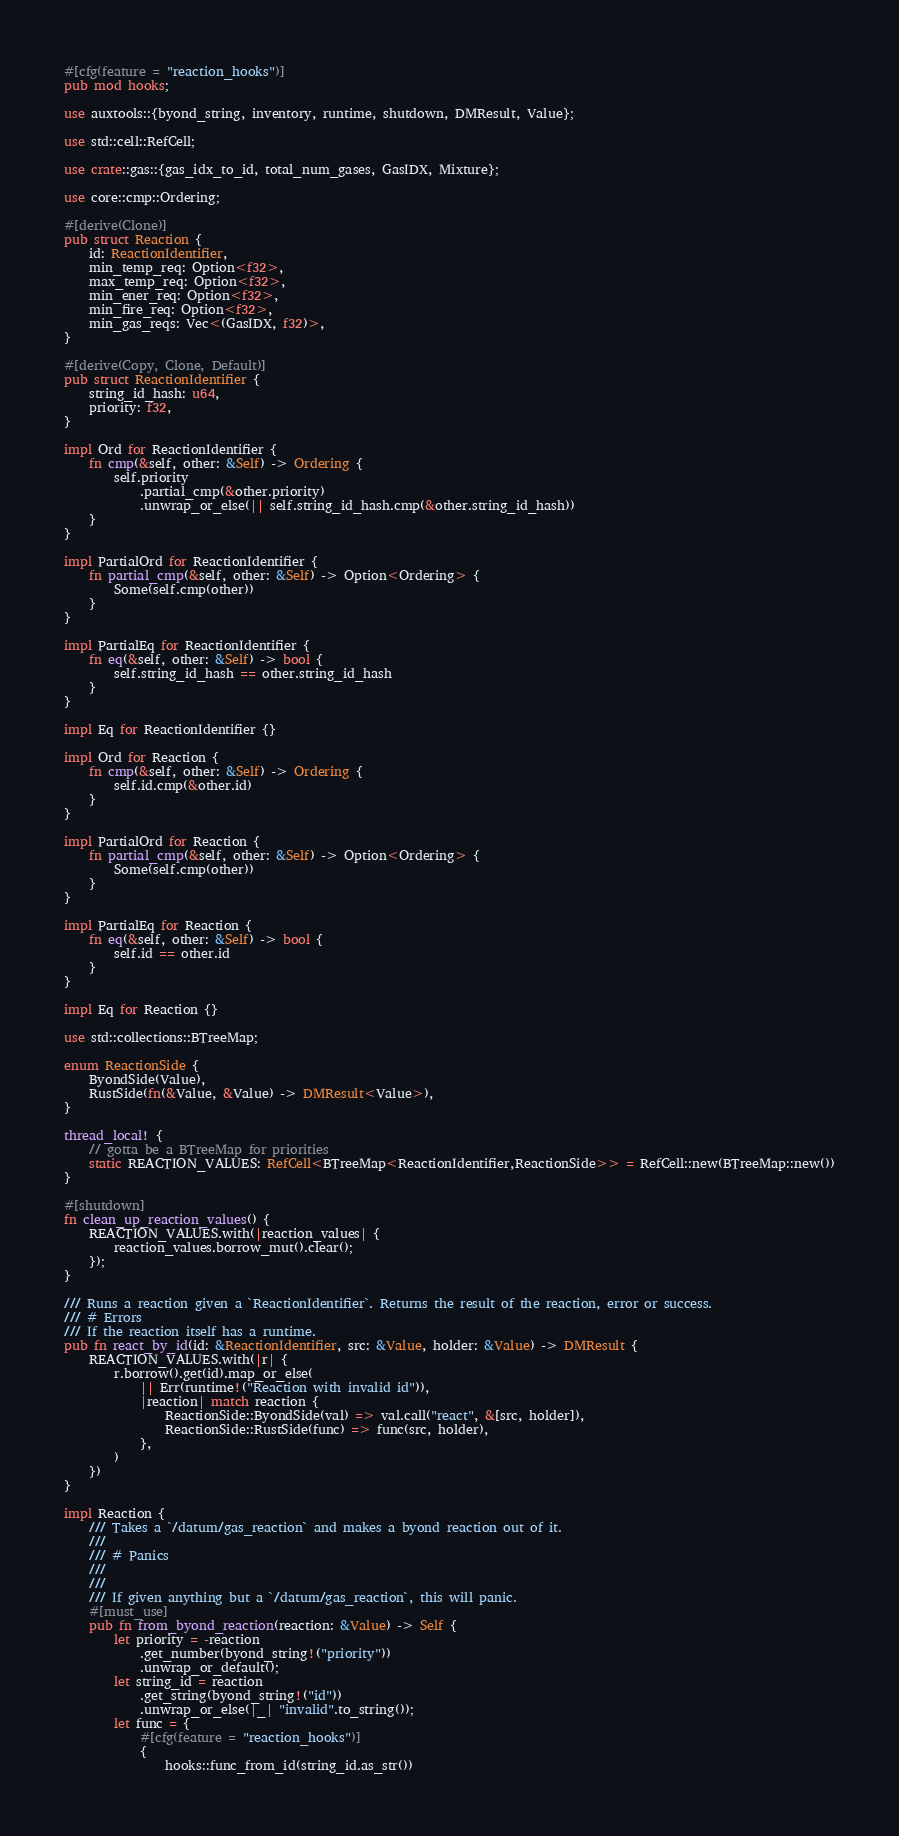<code> <loc_0><loc_0><loc_500><loc_500><_Rust_>#[cfg(feature = "reaction_hooks")]
pub mod hooks;

use auxtools::{byond_string, inventory, runtime, shutdown, DMResult, Value};

use std::cell::RefCell;

use crate::gas::{gas_idx_to_id, total_num_gases, GasIDX, Mixture};

use core::cmp::Ordering;

#[derive(Clone)]
pub struct Reaction {
	id: ReactionIdentifier,
	min_temp_req: Option<f32>,
	max_temp_req: Option<f32>,
	min_ener_req: Option<f32>,
	min_fire_req: Option<f32>,
	min_gas_reqs: Vec<(GasIDX, f32)>,
}

#[derive(Copy, Clone, Default)]
pub struct ReactionIdentifier {
	string_id_hash: u64,
	priority: f32,
}

impl Ord for ReactionIdentifier {
	fn cmp(&self, other: &Self) -> Ordering {
		self.priority
			.partial_cmp(&other.priority)
			.unwrap_or_else(|| self.string_id_hash.cmp(&other.string_id_hash))
	}
}

impl PartialOrd for ReactionIdentifier {
	fn partial_cmp(&self, other: &Self) -> Option<Ordering> {
		Some(self.cmp(other))
	}
}

impl PartialEq for ReactionIdentifier {
	fn eq(&self, other: &Self) -> bool {
		self.string_id_hash == other.string_id_hash
	}
}

impl Eq for ReactionIdentifier {}

impl Ord for Reaction {
	fn cmp(&self, other: &Self) -> Ordering {
		self.id.cmp(&other.id)
	}
}

impl PartialOrd for Reaction {
	fn partial_cmp(&self, other: &Self) -> Option<Ordering> {
		Some(self.cmp(other))
	}
}

impl PartialEq for Reaction {
	fn eq(&self, other: &Self) -> bool {
		self.id == other.id
	}
}

impl Eq for Reaction {}

use std::collections::BTreeMap;

enum ReactionSide {
	ByondSide(Value),
	RustSide(fn(&Value, &Value) -> DMResult<Value>),
}

thread_local! {
	// gotta be a BTreeMap for priorities
	static REACTION_VALUES: RefCell<BTreeMap<ReactionIdentifier,ReactionSide>> = RefCell::new(BTreeMap::new())
}

#[shutdown]
fn clean_up_reaction_values() {
	REACTION_VALUES.with(|reaction_values| {
		reaction_values.borrow_mut().clear();
	});
}

/// Runs a reaction given a `ReactionIdentifier`. Returns the result of the reaction, error or success.
/// # Errors
/// If the reaction itself has a runtime.
pub fn react_by_id(id: &ReactionIdentifier, src: &Value, holder: &Value) -> DMResult {
	REACTION_VALUES.with(|r| {
		r.borrow().get(id).map_or_else(
			|| Err(runtime!("Reaction with invalid id")),
			|reaction| match reaction {
				ReactionSide::ByondSide(val) => val.call("react", &[src, holder]),
				ReactionSide::RustSide(func) => func(src, holder),
			},
		)
	})
}

impl Reaction {
	/// Takes a `/datum/gas_reaction` and makes a byond reaction out of it.
	///
	/// # Panics
	///
	///
	/// If given anything but a `/datum/gas_reaction`, this will panic.
	#[must_use]
	pub fn from_byond_reaction(reaction: &Value) -> Self {
		let priority = -reaction
			.get_number(byond_string!("priority"))
			.unwrap_or_default();
		let string_id = reaction
			.get_string(byond_string!("id"))
			.unwrap_or_else(|_| "invalid".to_string());
		let func = {
			#[cfg(feature = "reaction_hooks")]
			{
				hooks::func_from_id(string_id.as_str())</code> 